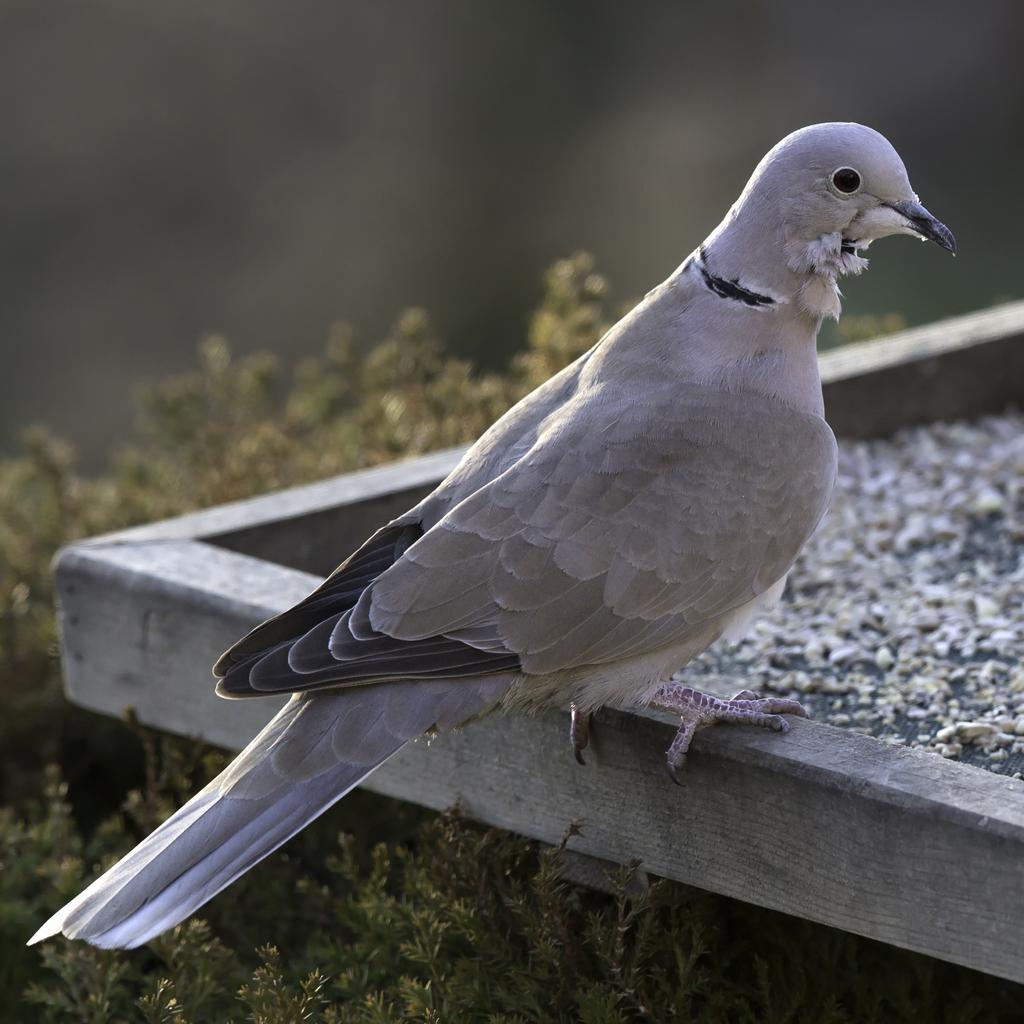Describe this image in one or two sentences. In this picture there is a pigeon in the center of the image and there are plants at the bottom side of the image. 